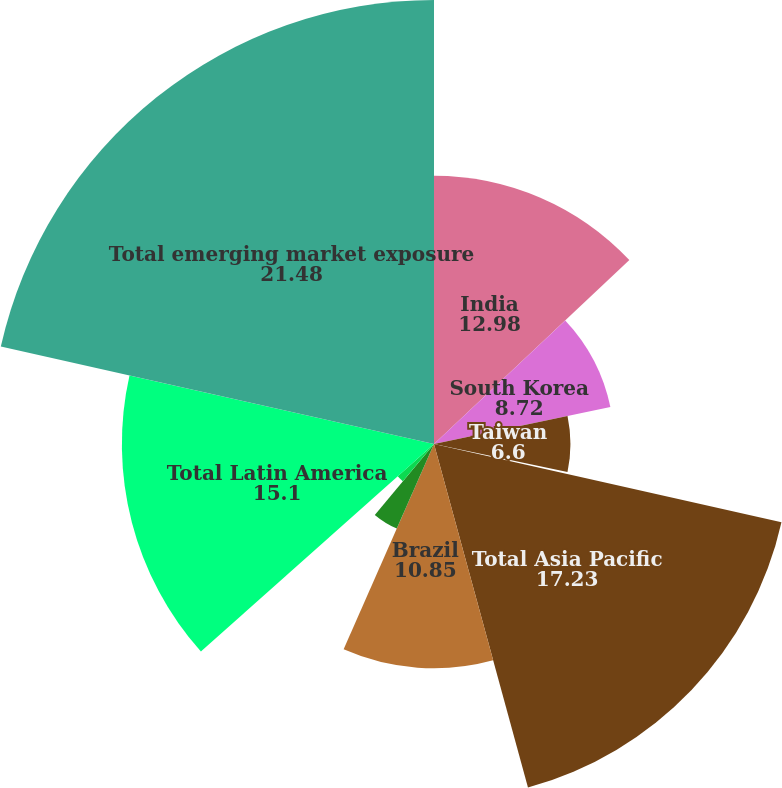<chart> <loc_0><loc_0><loc_500><loc_500><pie_chart><fcel>India<fcel>South Korea<fcel>Taiwan<fcel>Thailand<fcel>Total Asia Pacific<fcel>Brazil<fcel>Chile<fcel>Other Latin America (7)<fcel>Total Latin America<fcel>Total emerging market exposure<nl><fcel>12.98%<fcel>8.72%<fcel>6.6%<fcel>0.22%<fcel>17.23%<fcel>10.85%<fcel>4.47%<fcel>2.35%<fcel>15.1%<fcel>21.48%<nl></chart> 